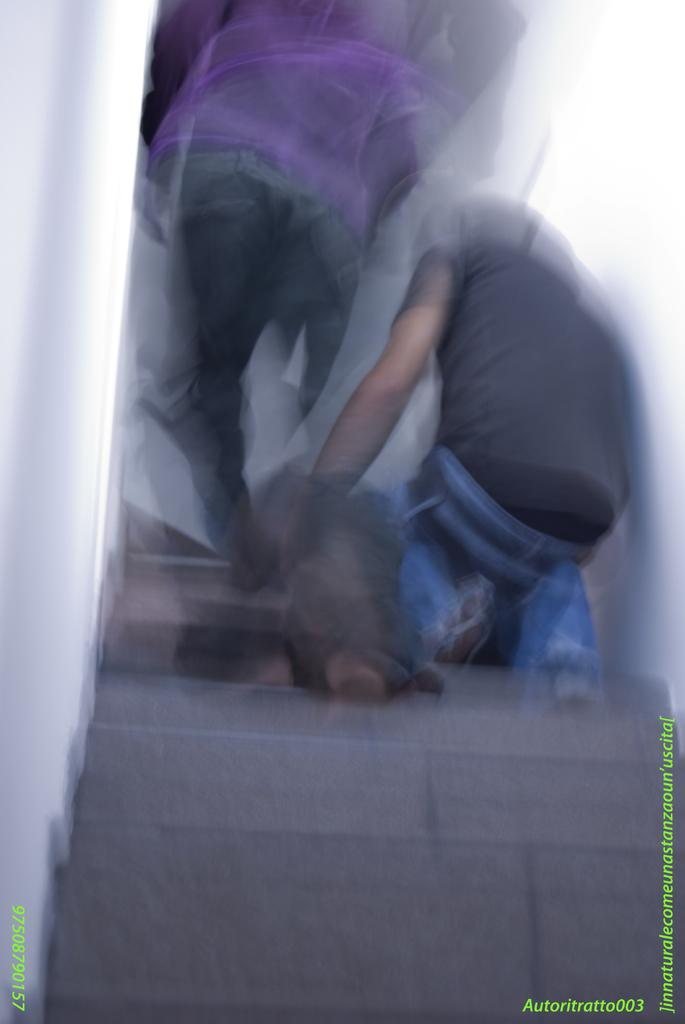What are the people doing in the image? The people are on steps in the image. Can you describe the steps in the image? Yes, there are steps in the image. What type of beam is being used by the people in the image? There is no beam present in the image; the people are on steps. How does the image convey the emotion of anger? The image does not convey any specific emotion, such as anger. 